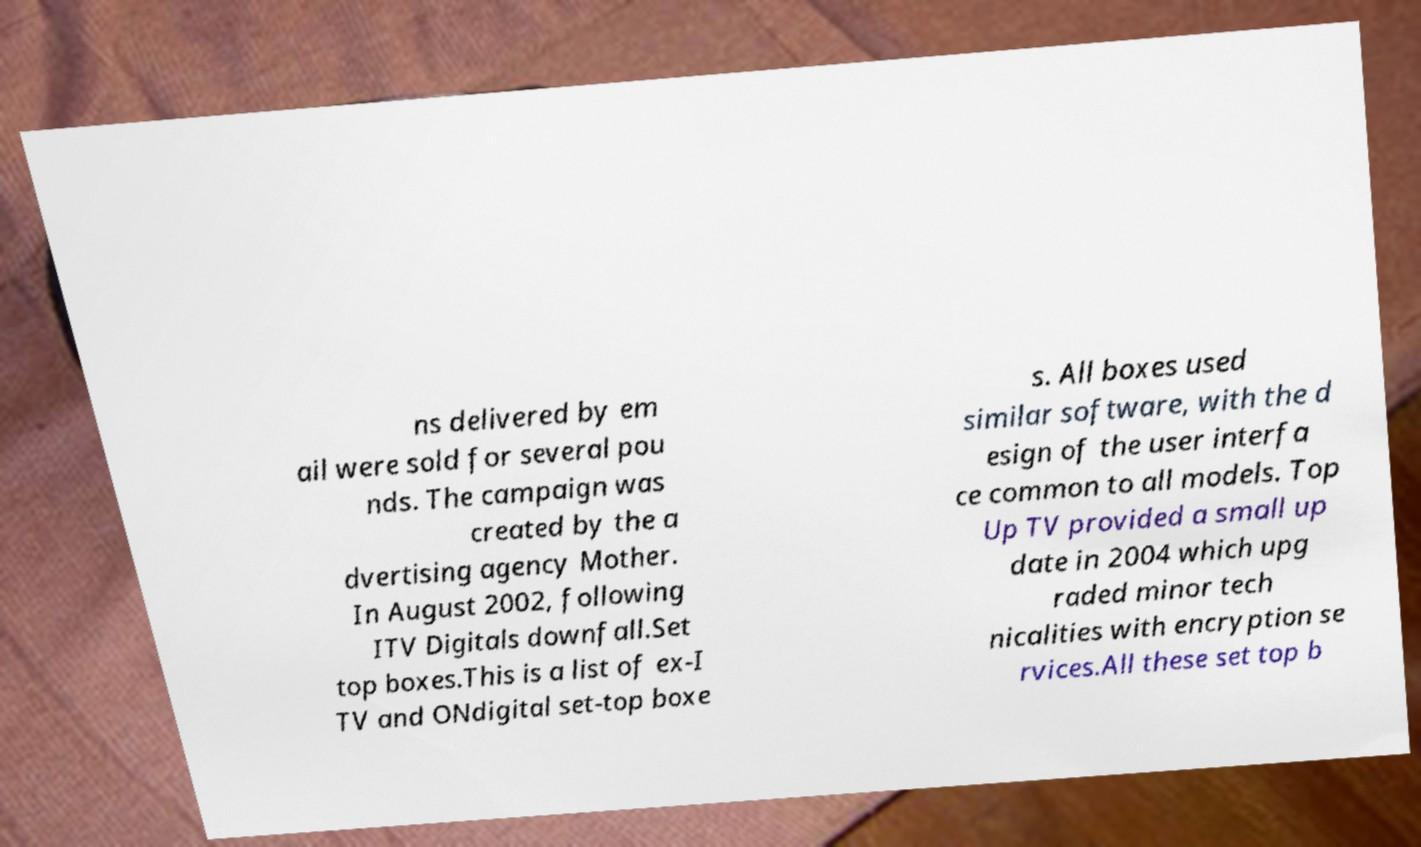Could you assist in decoding the text presented in this image and type it out clearly? ns delivered by em ail were sold for several pou nds. The campaign was created by the a dvertising agency Mother. In August 2002, following ITV Digitals downfall.Set top boxes.This is a list of ex-I TV and ONdigital set-top boxe s. All boxes used similar software, with the d esign of the user interfa ce common to all models. Top Up TV provided a small up date in 2004 which upg raded minor tech nicalities with encryption se rvices.All these set top b 